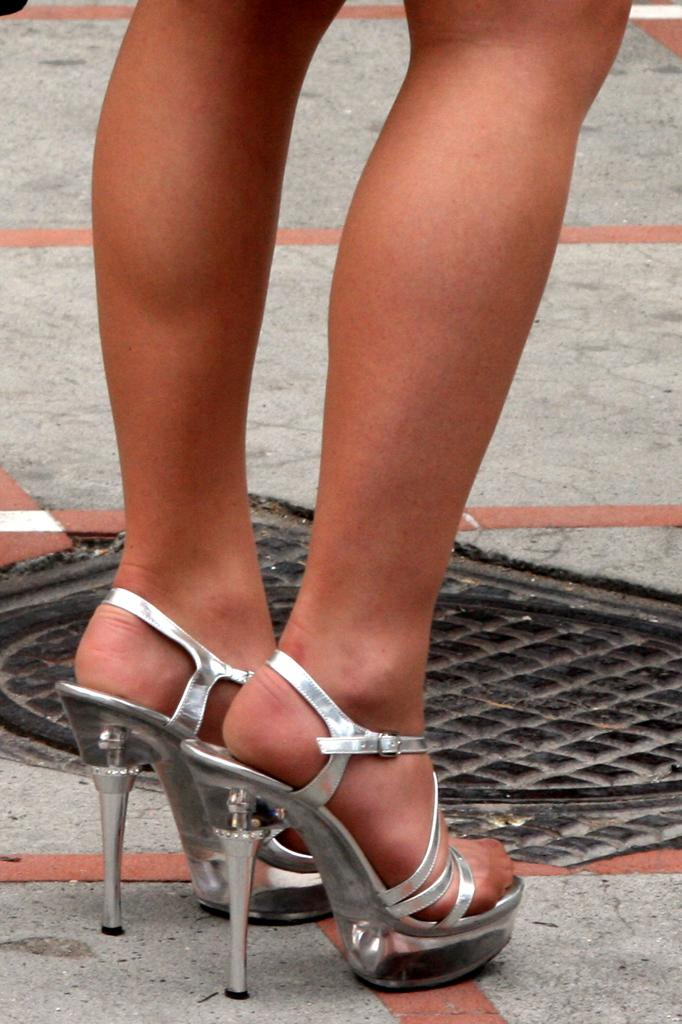What is present in the image? There is a person in the image. What can be observed about the person's footwear? The person is wearing silver-colored footwear. Where is the person standing? The person is standing on the ground. What is another object visible in the image? There is a black-colored manhole lid in the image. What type of leather is being used to make the channel in the image? There is no channel or leather present in the image. 